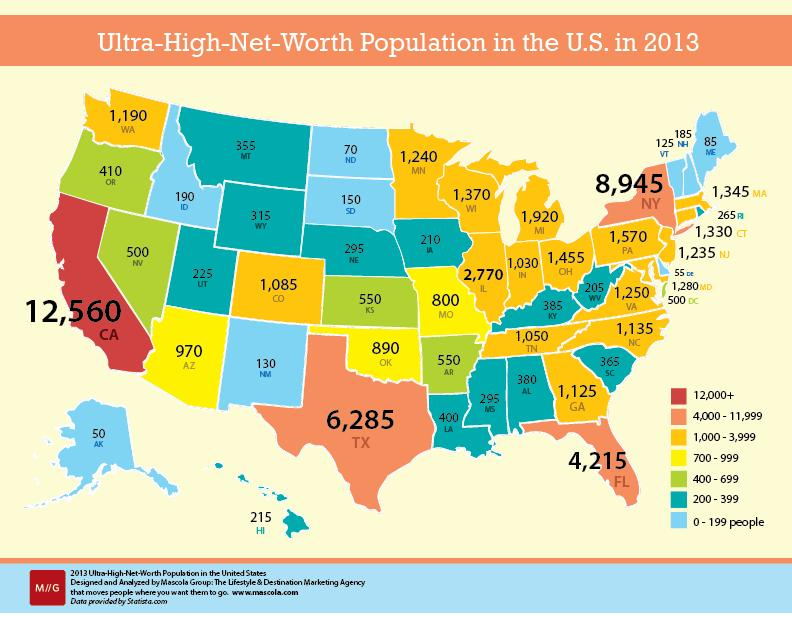Mention a couple of crucial points in this snapshot. Four states have an ultra-high-net-worth population of 4,000 to 11,999. Out of all the states in the United States, there are currently 18 states that have a population of ultra-high net worth individuals with a minimum wealth threshold of $120,000,000 or more. 